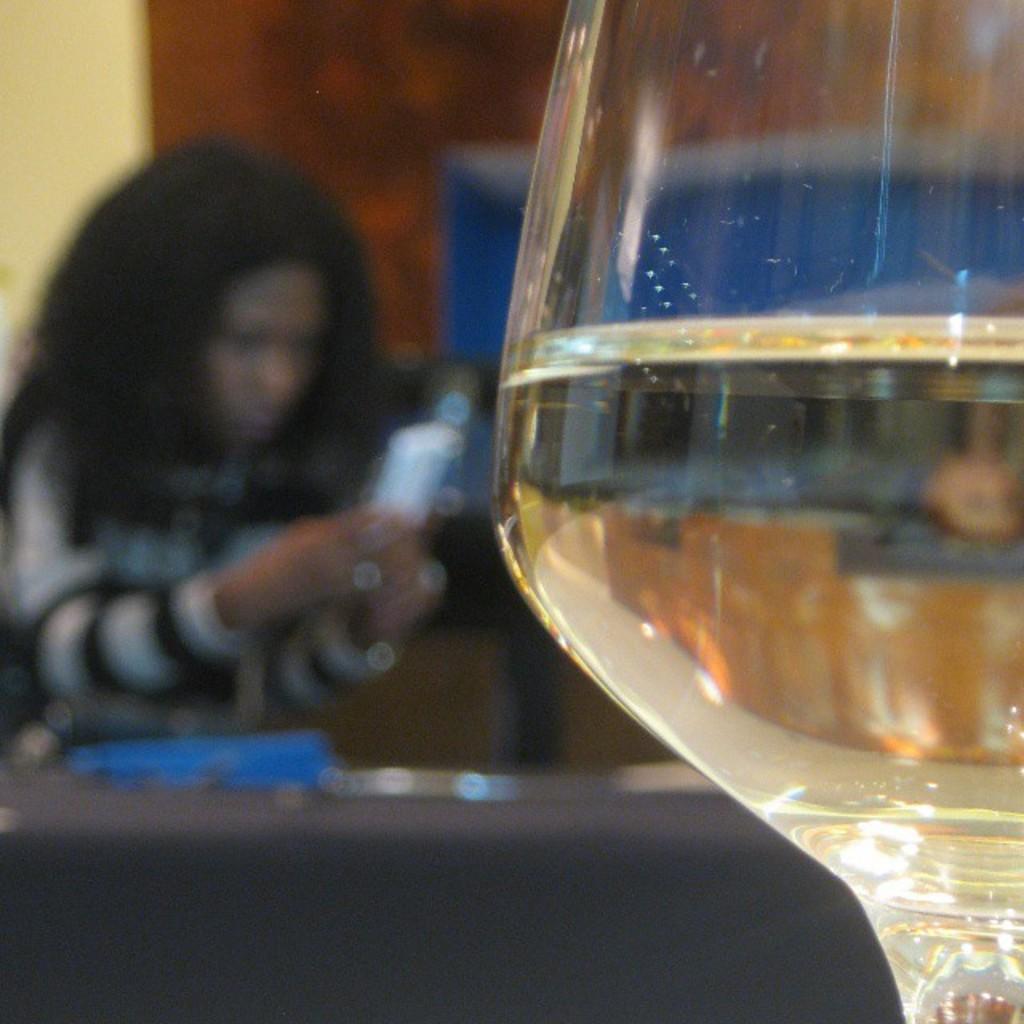In one or two sentences, can you explain what this image depicts? In this picture I can see a glass. In the background I can see a woman is holding something in the hand. The background of the image is blurred. 